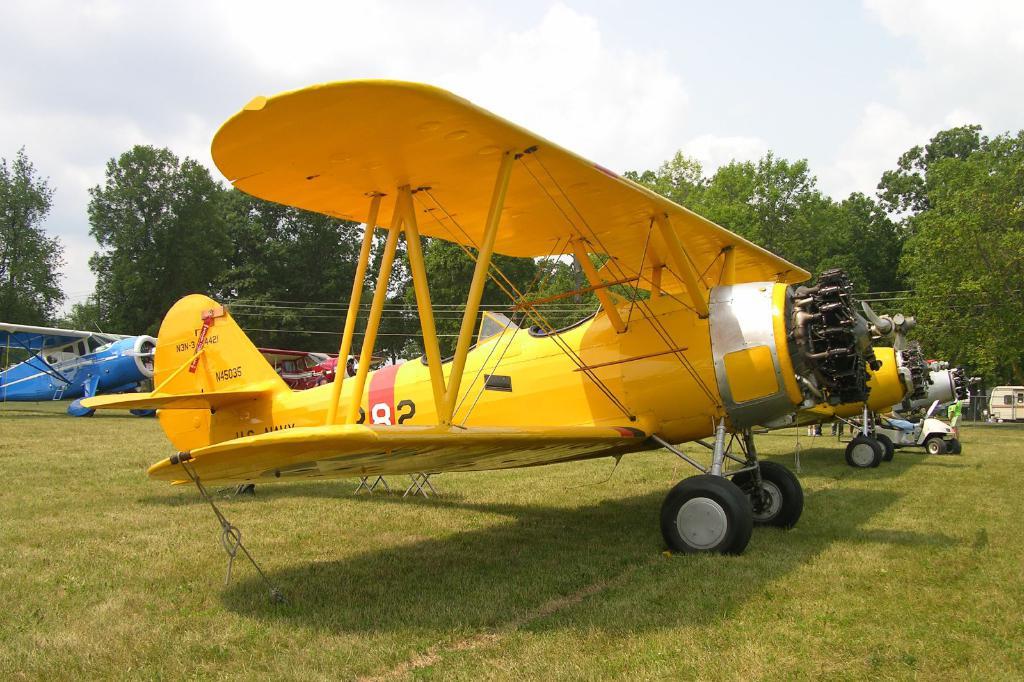What number is this plane?
Keep it short and to the point. 282. 